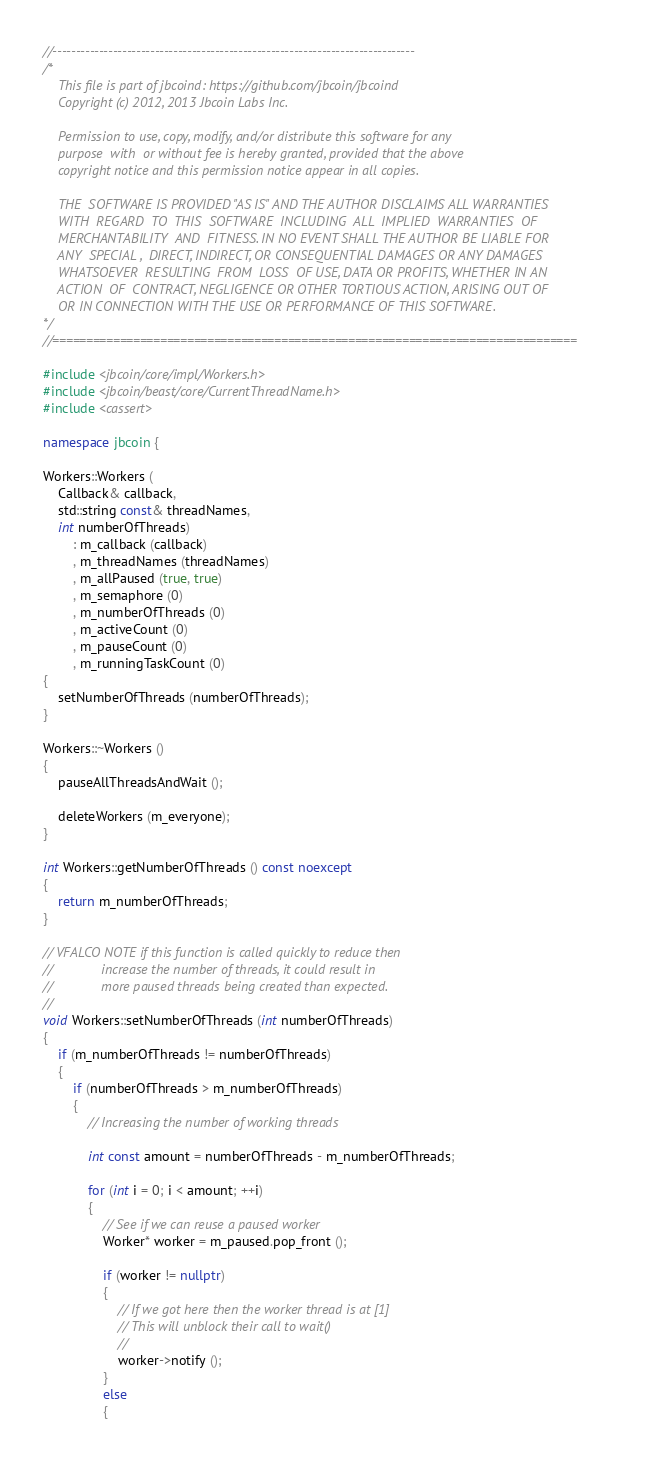<code> <loc_0><loc_0><loc_500><loc_500><_C++_>//------------------------------------------------------------------------------
/*
    This file is part of jbcoind: https://github.com/jbcoin/jbcoind
    Copyright (c) 2012, 2013 Jbcoin Labs Inc.

    Permission to use, copy, modify, and/or distribute this software for any
    purpose  with  or without fee is hereby granted, provided that the above
    copyright notice and this permission notice appear in all copies.

    THE  SOFTWARE IS PROVIDED "AS IS" AND THE AUTHOR DISCLAIMS ALL WARRANTIES
    WITH  REGARD  TO  THIS  SOFTWARE  INCLUDING  ALL  IMPLIED  WARRANTIES  OF
    MERCHANTABILITY  AND  FITNESS. IN NO EVENT SHALL THE AUTHOR BE LIABLE FOR
    ANY  SPECIAL ,  DIRECT, INDIRECT, OR CONSEQUENTIAL DAMAGES OR ANY DAMAGES
    WHATSOEVER  RESULTING  FROM  LOSS  OF USE, DATA OR PROFITS, WHETHER IN AN
    ACTION  OF  CONTRACT, NEGLIGENCE OR OTHER TORTIOUS ACTION, ARISING OUT OF
    OR IN CONNECTION WITH THE USE OR PERFORMANCE OF THIS SOFTWARE.
*/
//==============================================================================

#include <jbcoin/core/impl/Workers.h>
#include <jbcoin/beast/core/CurrentThreadName.h>
#include <cassert>

namespace jbcoin {

Workers::Workers (
    Callback& callback,
    std::string const& threadNames,
    int numberOfThreads)
        : m_callback (callback)
        , m_threadNames (threadNames)
        , m_allPaused (true, true)
        , m_semaphore (0)
        , m_numberOfThreads (0)
        , m_activeCount (0)
        , m_pauseCount (0)
        , m_runningTaskCount (0)
{
    setNumberOfThreads (numberOfThreads);
}

Workers::~Workers ()
{
    pauseAllThreadsAndWait ();

    deleteWorkers (m_everyone);
}

int Workers::getNumberOfThreads () const noexcept
{
    return m_numberOfThreads;
}

// VFALCO NOTE if this function is called quickly to reduce then
//             increase the number of threads, it could result in
//             more paused threads being created than expected.
//
void Workers::setNumberOfThreads (int numberOfThreads)
{
    if (m_numberOfThreads != numberOfThreads)
    {
        if (numberOfThreads > m_numberOfThreads)
        {
            // Increasing the number of working threads

            int const amount = numberOfThreads - m_numberOfThreads;

            for (int i = 0; i < amount; ++i)
            {
                // See if we can reuse a paused worker
                Worker* worker = m_paused.pop_front ();

                if (worker != nullptr)
                {
                    // If we got here then the worker thread is at [1]
                    // This will unblock their call to wait()
                    //
                    worker->notify ();
                }
                else
                {</code> 